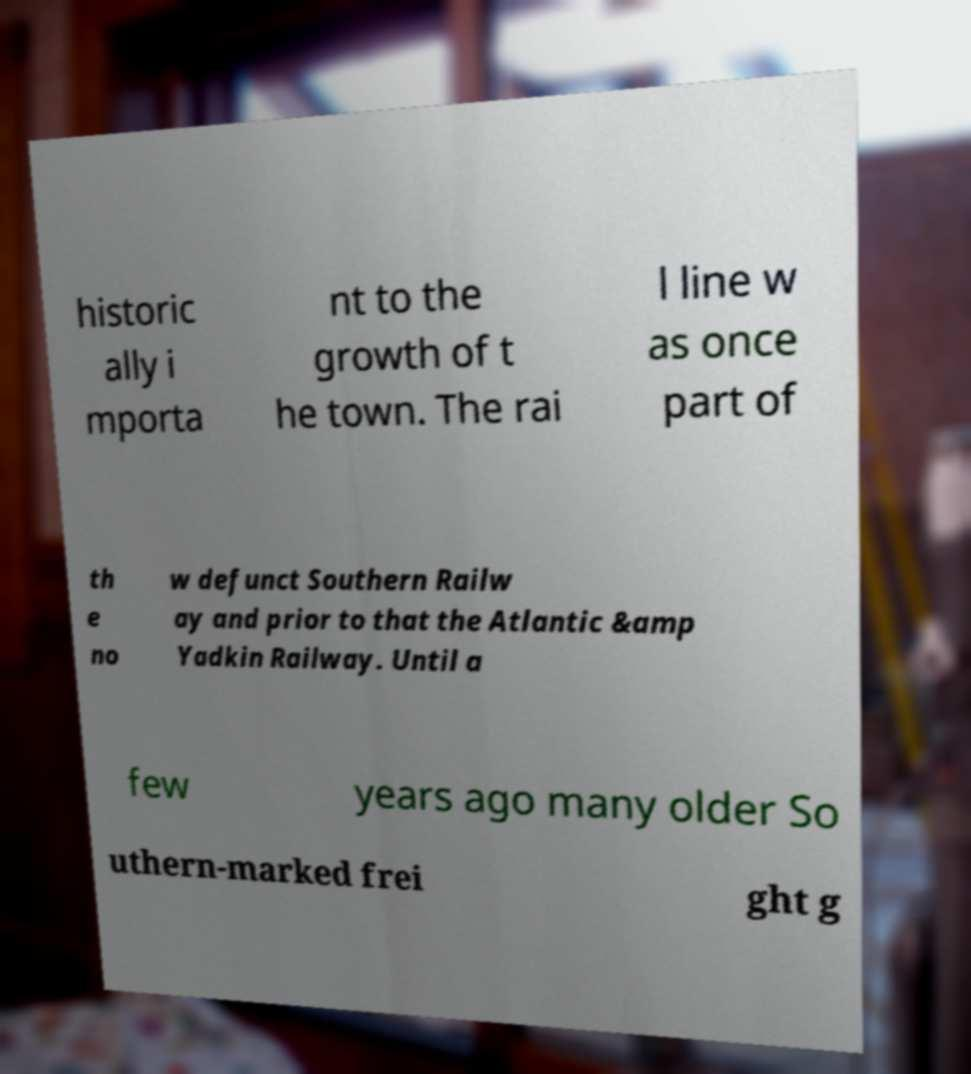I need the written content from this picture converted into text. Can you do that? historic ally i mporta nt to the growth of t he town. The rai l line w as once part of th e no w defunct Southern Railw ay and prior to that the Atlantic &amp Yadkin Railway. Until a few years ago many older So uthern-marked frei ght g 